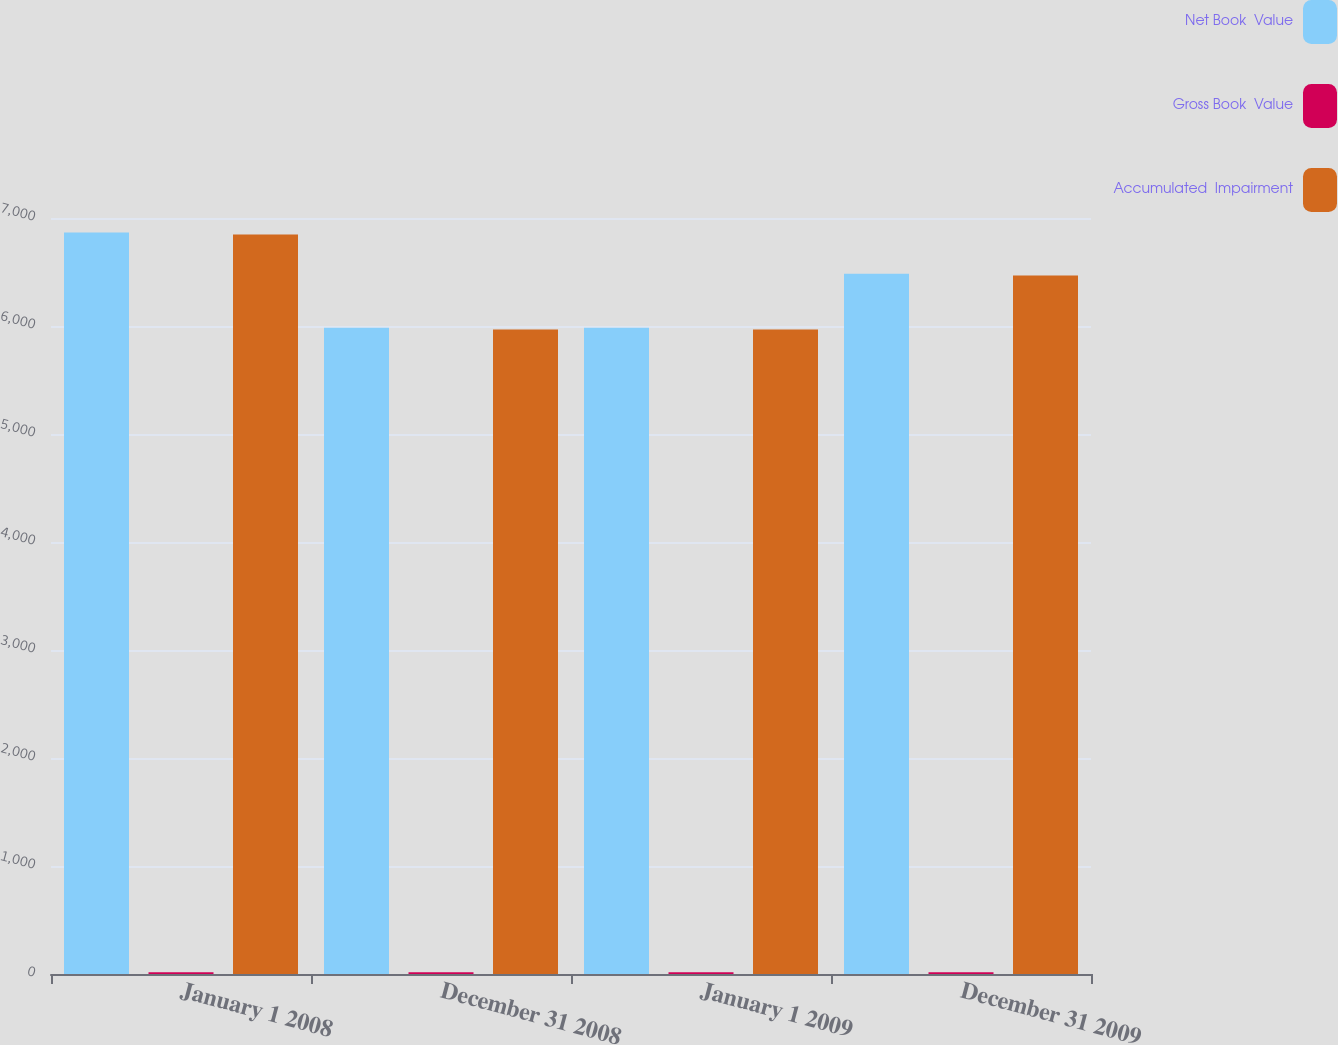<chart> <loc_0><loc_0><loc_500><loc_500><stacked_bar_chart><ecel><fcel>January 1 2008<fcel>December 31 2008<fcel>January 1 2009<fcel>December 31 2009<nl><fcel>Net Book  Value<fcel>6864.6<fcel>5983.4<fcel>5983.4<fcel>6484.2<nl><fcel>Gross Book  Value<fcel>16.6<fcel>16.6<fcel>16.6<fcel>16.6<nl><fcel>Accumulated  Impairment<fcel>6848<fcel>5966.8<fcel>5966.8<fcel>6467.6<nl></chart> 